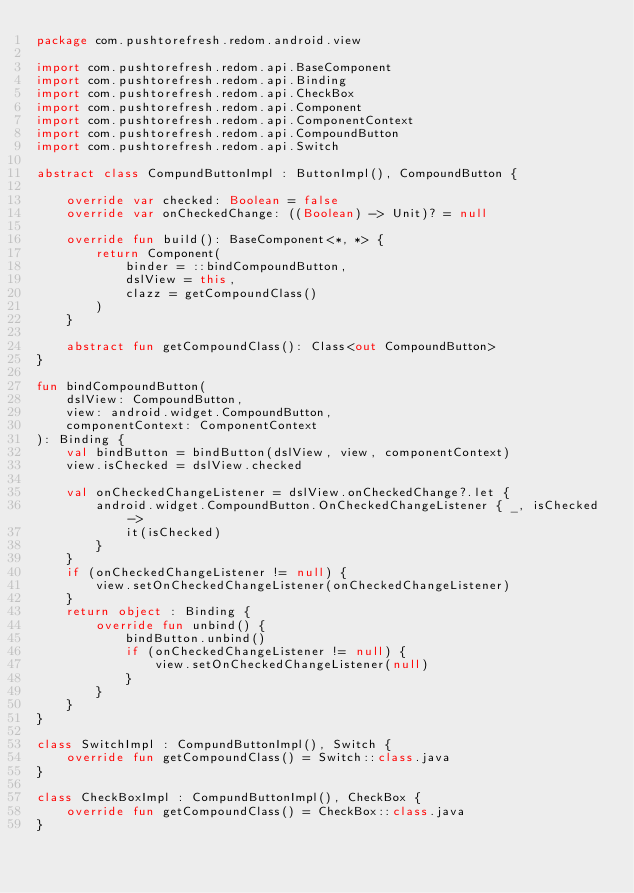Convert code to text. <code><loc_0><loc_0><loc_500><loc_500><_Kotlin_>package com.pushtorefresh.redom.android.view

import com.pushtorefresh.redom.api.BaseComponent
import com.pushtorefresh.redom.api.Binding
import com.pushtorefresh.redom.api.CheckBox
import com.pushtorefresh.redom.api.Component
import com.pushtorefresh.redom.api.ComponentContext
import com.pushtorefresh.redom.api.CompoundButton
import com.pushtorefresh.redom.api.Switch

abstract class CompundButtonImpl : ButtonImpl(), CompoundButton {

    override var checked: Boolean = false
    override var onCheckedChange: ((Boolean) -> Unit)? = null

    override fun build(): BaseComponent<*, *> {
        return Component(
            binder = ::bindCompoundButton,
            dslView = this,
            clazz = getCompoundClass()
        )
    }

    abstract fun getCompoundClass(): Class<out CompoundButton>
}

fun bindCompoundButton(
    dslView: CompoundButton,
    view: android.widget.CompoundButton,
    componentContext: ComponentContext
): Binding {
    val bindButton = bindButton(dslView, view, componentContext)
    view.isChecked = dslView.checked

    val onCheckedChangeListener = dslView.onCheckedChange?.let {
        android.widget.CompoundButton.OnCheckedChangeListener { _, isChecked ->
            it(isChecked)
        }
    }
    if (onCheckedChangeListener != null) {
        view.setOnCheckedChangeListener(onCheckedChangeListener)
    }
    return object : Binding {
        override fun unbind() {
            bindButton.unbind()
            if (onCheckedChangeListener != null) {
                view.setOnCheckedChangeListener(null)
            }
        }
    }
}

class SwitchImpl : CompundButtonImpl(), Switch {
    override fun getCompoundClass() = Switch::class.java
}

class CheckBoxImpl : CompundButtonImpl(), CheckBox {
    override fun getCompoundClass() = CheckBox::class.java
}
</code> 